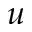Convert formula to latex. <formula><loc_0><loc_0><loc_500><loc_500>u</formula> 